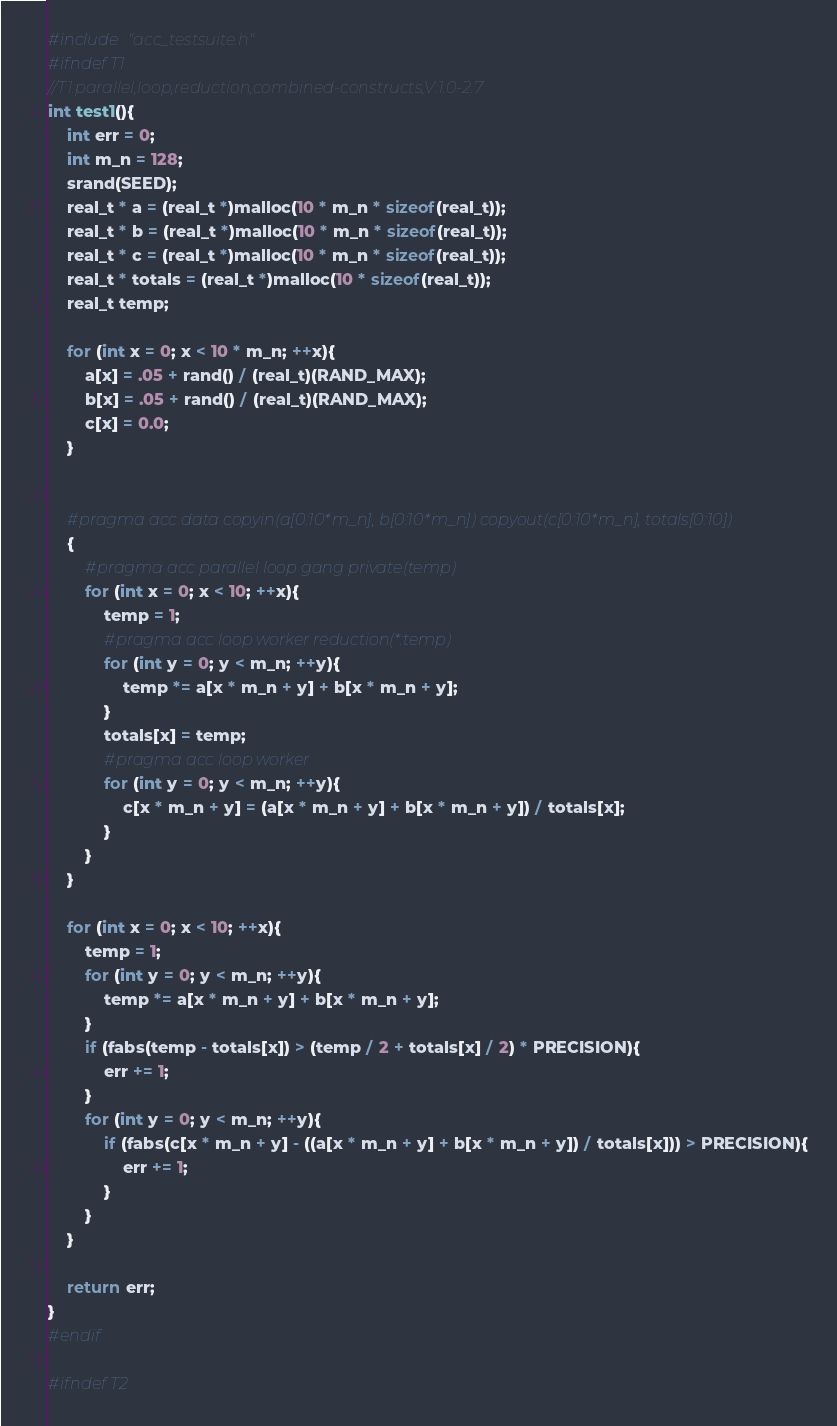<code> <loc_0><loc_0><loc_500><loc_500><_C_>#include "acc_testsuite.h"
#ifndef T1
//T1:parallel,loop,reduction,combined-constructs,V:1.0-2.7
int test1(){
    int err = 0;
    int m_n = 128;
    srand(SEED);
    real_t * a = (real_t *)malloc(10 * m_n * sizeof(real_t));
    real_t * b = (real_t *)malloc(10 * m_n * sizeof(real_t));
    real_t * c = (real_t *)malloc(10 * m_n * sizeof(real_t));
    real_t * totals = (real_t *)malloc(10 * sizeof(real_t));
    real_t temp;

    for (int x = 0; x < 10 * m_n; ++x){
        a[x] = .05 + rand() / (real_t)(RAND_MAX);
        b[x] = .05 + rand() / (real_t)(RAND_MAX);
        c[x] = 0.0;
    }


    #pragma acc data copyin(a[0:10*m_n], b[0:10*m_n]) copyout(c[0:10*m_n], totals[0:10])
    {
        #pragma acc parallel loop gang private(temp)
        for (int x = 0; x < 10; ++x){
            temp = 1;
            #pragma acc loop worker reduction(*:temp)
            for (int y = 0; y < m_n; ++y){
                temp *= a[x * m_n + y] + b[x * m_n + y];
            }
            totals[x] = temp;
            #pragma acc loop worker
            for (int y = 0; y < m_n; ++y){
                c[x * m_n + y] = (a[x * m_n + y] + b[x * m_n + y]) / totals[x];
            }
        }
    }

    for (int x = 0; x < 10; ++x){
        temp = 1;
        for (int y = 0; y < m_n; ++y){
            temp *= a[x * m_n + y] + b[x * m_n + y];
        }
        if (fabs(temp - totals[x]) > (temp / 2 + totals[x] / 2) * PRECISION){
            err += 1;
        }
        for (int y = 0; y < m_n; ++y){
            if (fabs(c[x * m_n + y] - ((a[x * m_n + y] + b[x * m_n + y]) / totals[x])) > PRECISION){
                err += 1;
            }
        }
    }

    return err;
}
#endif

#ifndef T2</code> 